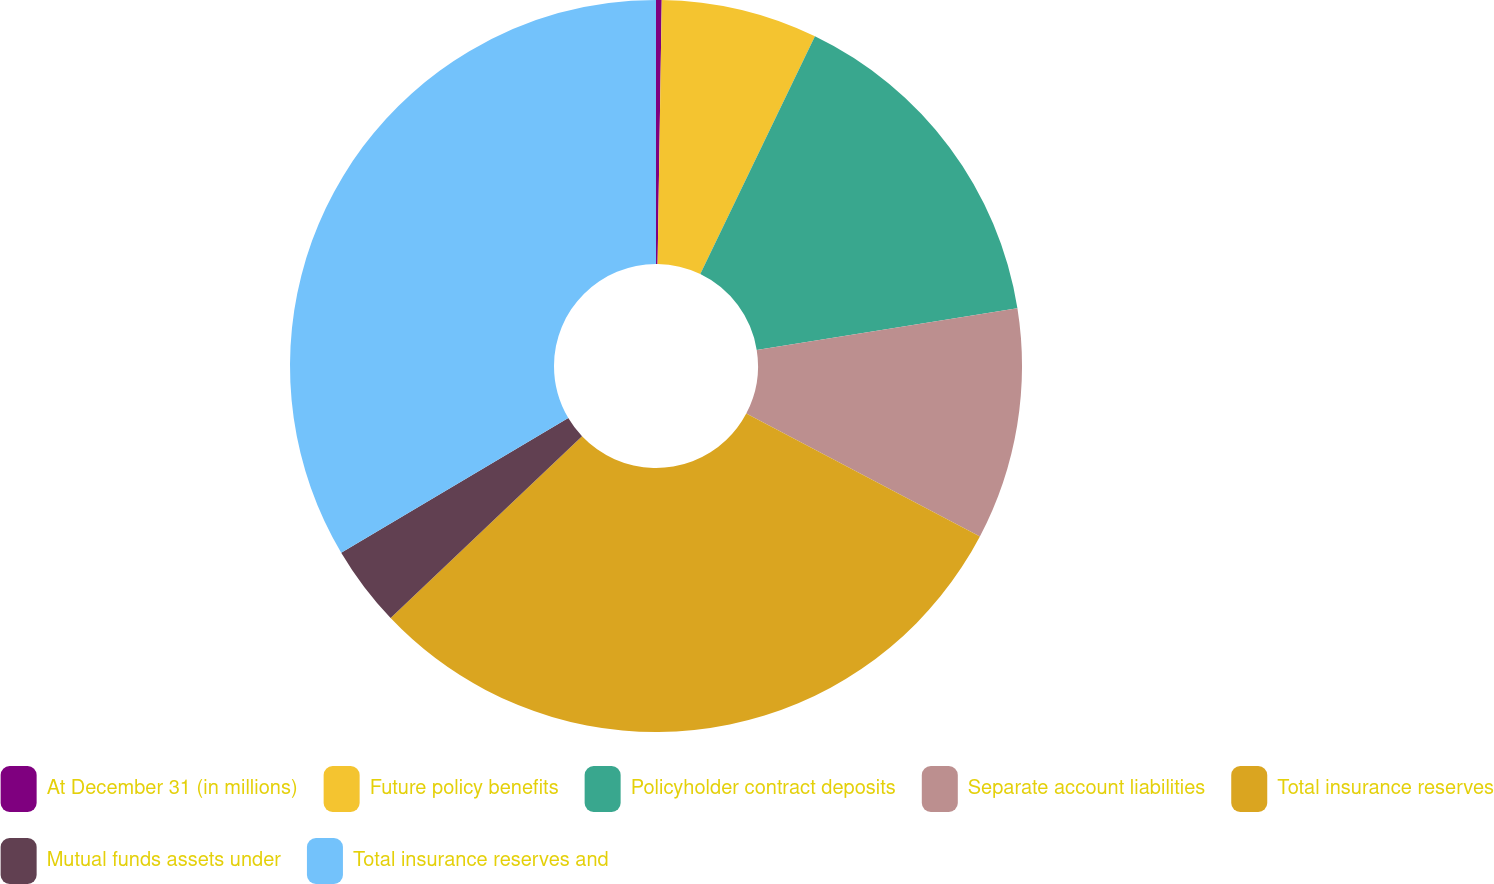Convert chart to OTSL. <chart><loc_0><loc_0><loc_500><loc_500><pie_chart><fcel>At December 31 (in millions)<fcel>Future policy benefits<fcel>Policyholder contract deposits<fcel>Separate account liabilities<fcel>Total insurance reserves<fcel>Mutual funds assets under<fcel>Total insurance reserves and<nl><fcel>0.25%<fcel>6.9%<fcel>15.33%<fcel>10.23%<fcel>30.2%<fcel>3.57%<fcel>33.52%<nl></chart> 